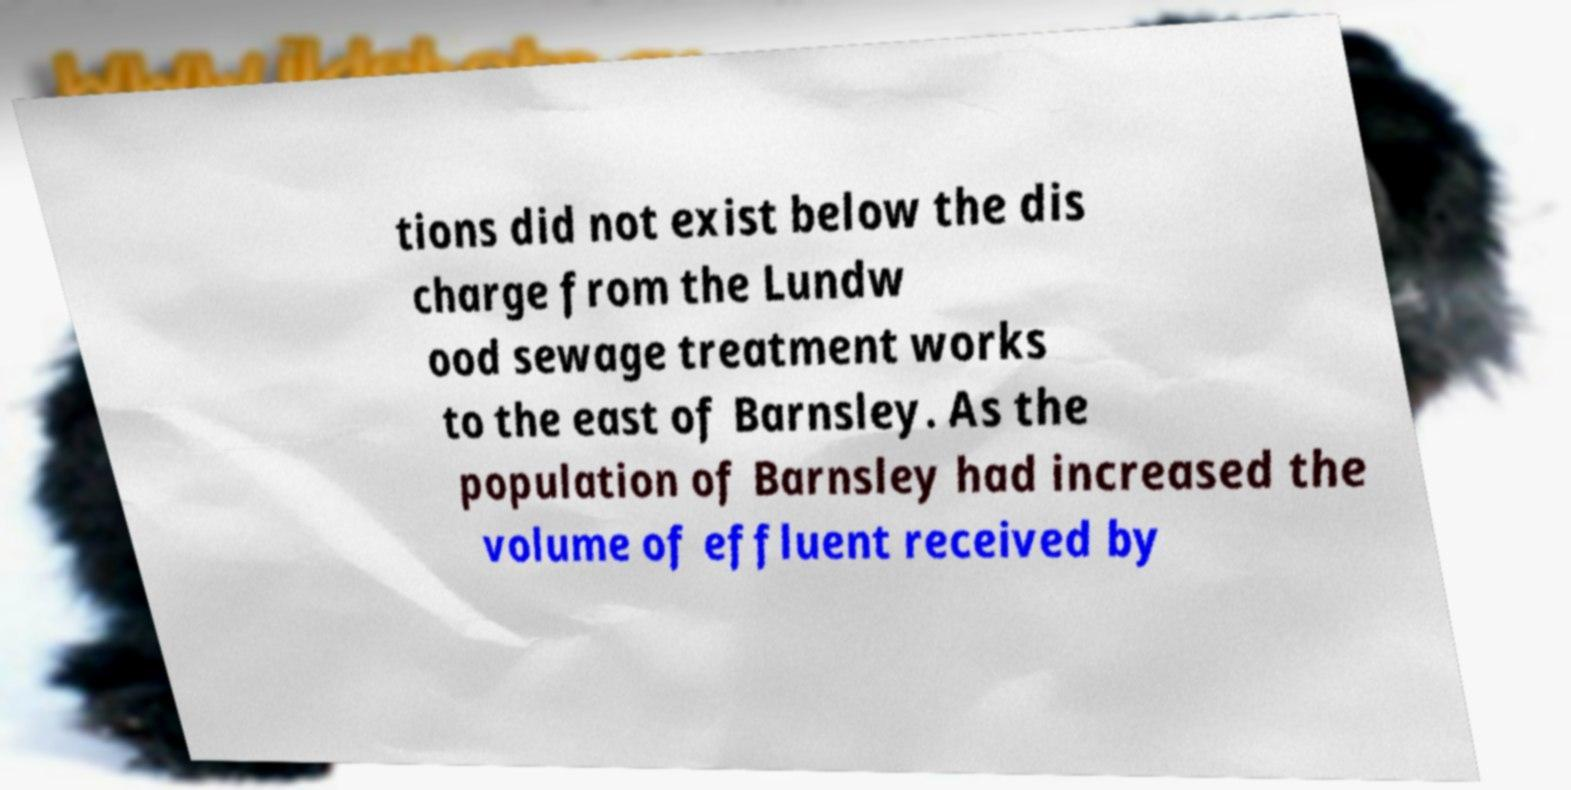There's text embedded in this image that I need extracted. Can you transcribe it verbatim? tions did not exist below the dis charge from the Lundw ood sewage treatment works to the east of Barnsley. As the population of Barnsley had increased the volume of effluent received by 